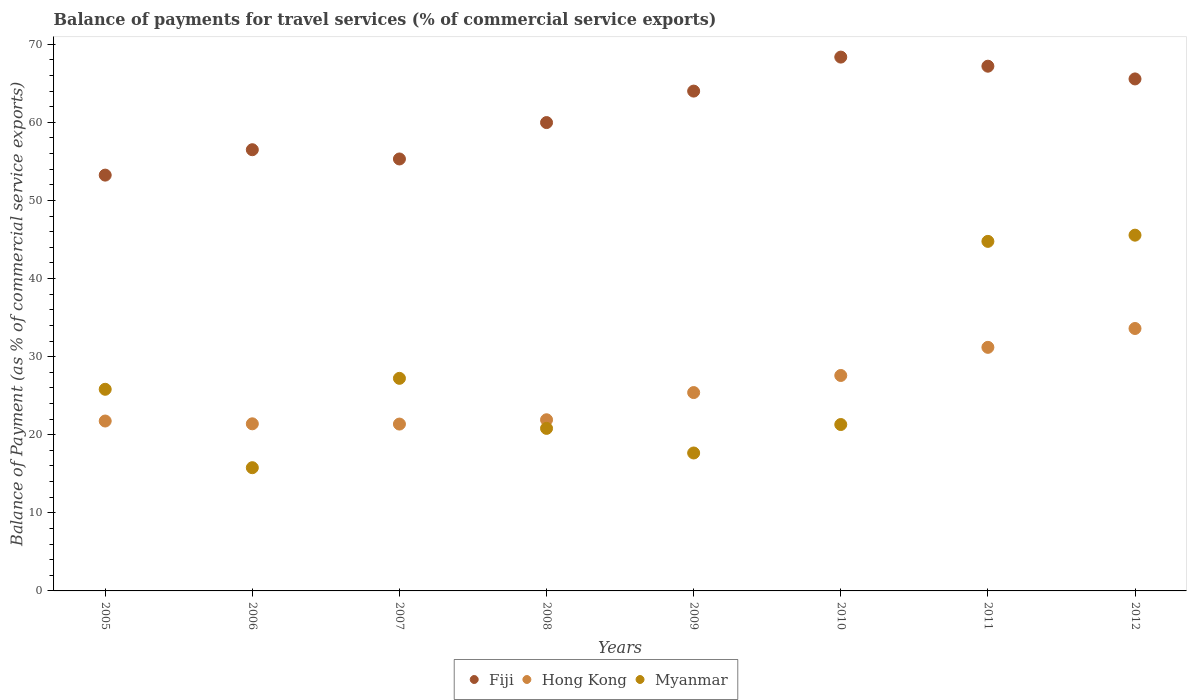Is the number of dotlines equal to the number of legend labels?
Keep it short and to the point. Yes. What is the balance of payments for travel services in Myanmar in 2009?
Your answer should be compact. 17.66. Across all years, what is the maximum balance of payments for travel services in Fiji?
Ensure brevity in your answer.  68.36. Across all years, what is the minimum balance of payments for travel services in Myanmar?
Provide a short and direct response. 15.78. What is the total balance of payments for travel services in Fiji in the graph?
Your answer should be very brief. 490.14. What is the difference between the balance of payments for travel services in Fiji in 2006 and that in 2010?
Give a very brief answer. -11.86. What is the difference between the balance of payments for travel services in Fiji in 2006 and the balance of payments for travel services in Hong Kong in 2009?
Provide a succinct answer. 31.1. What is the average balance of payments for travel services in Myanmar per year?
Ensure brevity in your answer.  27.36. In the year 2009, what is the difference between the balance of payments for travel services in Fiji and balance of payments for travel services in Myanmar?
Your answer should be very brief. 46.34. In how many years, is the balance of payments for travel services in Hong Kong greater than 10 %?
Make the answer very short. 8. What is the ratio of the balance of payments for travel services in Hong Kong in 2006 to that in 2009?
Your response must be concise. 0.84. What is the difference between the highest and the second highest balance of payments for travel services in Fiji?
Your response must be concise. 1.16. What is the difference between the highest and the lowest balance of payments for travel services in Fiji?
Ensure brevity in your answer.  15.11. In how many years, is the balance of payments for travel services in Fiji greater than the average balance of payments for travel services in Fiji taken over all years?
Offer a very short reply. 4. Is the sum of the balance of payments for travel services in Myanmar in 2005 and 2007 greater than the maximum balance of payments for travel services in Fiji across all years?
Give a very brief answer. No. Is the balance of payments for travel services in Myanmar strictly greater than the balance of payments for travel services in Fiji over the years?
Provide a succinct answer. No. How many years are there in the graph?
Offer a terse response. 8. Are the values on the major ticks of Y-axis written in scientific E-notation?
Your answer should be very brief. No. Does the graph contain grids?
Provide a succinct answer. No. How many legend labels are there?
Your answer should be very brief. 3. How are the legend labels stacked?
Your answer should be compact. Horizontal. What is the title of the graph?
Your answer should be very brief. Balance of payments for travel services (% of commercial service exports). What is the label or title of the Y-axis?
Provide a short and direct response. Balance of Payment (as % of commercial service exports). What is the Balance of Payment (as % of commercial service exports) in Fiji in 2005?
Your answer should be compact. 53.24. What is the Balance of Payment (as % of commercial service exports) of Hong Kong in 2005?
Your answer should be compact. 21.76. What is the Balance of Payment (as % of commercial service exports) of Myanmar in 2005?
Give a very brief answer. 25.82. What is the Balance of Payment (as % of commercial service exports) of Fiji in 2006?
Provide a short and direct response. 56.5. What is the Balance of Payment (as % of commercial service exports) in Hong Kong in 2006?
Provide a succinct answer. 21.4. What is the Balance of Payment (as % of commercial service exports) in Myanmar in 2006?
Provide a succinct answer. 15.78. What is the Balance of Payment (as % of commercial service exports) of Fiji in 2007?
Provide a succinct answer. 55.31. What is the Balance of Payment (as % of commercial service exports) of Hong Kong in 2007?
Provide a succinct answer. 21.37. What is the Balance of Payment (as % of commercial service exports) in Myanmar in 2007?
Provide a succinct answer. 27.22. What is the Balance of Payment (as % of commercial service exports) in Fiji in 2008?
Your answer should be compact. 59.97. What is the Balance of Payment (as % of commercial service exports) of Hong Kong in 2008?
Ensure brevity in your answer.  21.92. What is the Balance of Payment (as % of commercial service exports) of Myanmar in 2008?
Provide a succinct answer. 20.81. What is the Balance of Payment (as % of commercial service exports) of Fiji in 2009?
Your answer should be very brief. 64. What is the Balance of Payment (as % of commercial service exports) in Hong Kong in 2009?
Make the answer very short. 25.4. What is the Balance of Payment (as % of commercial service exports) in Myanmar in 2009?
Ensure brevity in your answer.  17.66. What is the Balance of Payment (as % of commercial service exports) of Fiji in 2010?
Provide a succinct answer. 68.36. What is the Balance of Payment (as % of commercial service exports) of Hong Kong in 2010?
Your answer should be very brief. 27.59. What is the Balance of Payment (as % of commercial service exports) in Myanmar in 2010?
Ensure brevity in your answer.  21.31. What is the Balance of Payment (as % of commercial service exports) in Fiji in 2011?
Ensure brevity in your answer.  67.19. What is the Balance of Payment (as % of commercial service exports) in Hong Kong in 2011?
Give a very brief answer. 31.19. What is the Balance of Payment (as % of commercial service exports) of Myanmar in 2011?
Keep it short and to the point. 44.76. What is the Balance of Payment (as % of commercial service exports) in Fiji in 2012?
Offer a terse response. 65.56. What is the Balance of Payment (as % of commercial service exports) of Hong Kong in 2012?
Your response must be concise. 33.6. What is the Balance of Payment (as % of commercial service exports) of Myanmar in 2012?
Provide a succinct answer. 45.56. Across all years, what is the maximum Balance of Payment (as % of commercial service exports) in Fiji?
Offer a terse response. 68.36. Across all years, what is the maximum Balance of Payment (as % of commercial service exports) in Hong Kong?
Your answer should be very brief. 33.6. Across all years, what is the maximum Balance of Payment (as % of commercial service exports) of Myanmar?
Make the answer very short. 45.56. Across all years, what is the minimum Balance of Payment (as % of commercial service exports) of Fiji?
Offer a terse response. 53.24. Across all years, what is the minimum Balance of Payment (as % of commercial service exports) in Hong Kong?
Make the answer very short. 21.37. Across all years, what is the minimum Balance of Payment (as % of commercial service exports) of Myanmar?
Provide a succinct answer. 15.78. What is the total Balance of Payment (as % of commercial service exports) of Fiji in the graph?
Provide a short and direct response. 490.14. What is the total Balance of Payment (as % of commercial service exports) of Hong Kong in the graph?
Keep it short and to the point. 204.22. What is the total Balance of Payment (as % of commercial service exports) in Myanmar in the graph?
Provide a succinct answer. 218.92. What is the difference between the Balance of Payment (as % of commercial service exports) in Fiji in 2005 and that in 2006?
Ensure brevity in your answer.  -3.25. What is the difference between the Balance of Payment (as % of commercial service exports) in Hong Kong in 2005 and that in 2006?
Your response must be concise. 0.36. What is the difference between the Balance of Payment (as % of commercial service exports) of Myanmar in 2005 and that in 2006?
Ensure brevity in your answer.  10.04. What is the difference between the Balance of Payment (as % of commercial service exports) of Fiji in 2005 and that in 2007?
Your answer should be very brief. -2.07. What is the difference between the Balance of Payment (as % of commercial service exports) in Hong Kong in 2005 and that in 2007?
Keep it short and to the point. 0.39. What is the difference between the Balance of Payment (as % of commercial service exports) of Myanmar in 2005 and that in 2007?
Offer a very short reply. -1.4. What is the difference between the Balance of Payment (as % of commercial service exports) of Fiji in 2005 and that in 2008?
Your response must be concise. -6.73. What is the difference between the Balance of Payment (as % of commercial service exports) of Hong Kong in 2005 and that in 2008?
Provide a short and direct response. -0.16. What is the difference between the Balance of Payment (as % of commercial service exports) in Myanmar in 2005 and that in 2008?
Your answer should be compact. 5.01. What is the difference between the Balance of Payment (as % of commercial service exports) in Fiji in 2005 and that in 2009?
Make the answer very short. -10.76. What is the difference between the Balance of Payment (as % of commercial service exports) in Hong Kong in 2005 and that in 2009?
Offer a terse response. -3.64. What is the difference between the Balance of Payment (as % of commercial service exports) of Myanmar in 2005 and that in 2009?
Your response must be concise. 8.16. What is the difference between the Balance of Payment (as % of commercial service exports) in Fiji in 2005 and that in 2010?
Offer a very short reply. -15.11. What is the difference between the Balance of Payment (as % of commercial service exports) of Hong Kong in 2005 and that in 2010?
Make the answer very short. -5.83. What is the difference between the Balance of Payment (as % of commercial service exports) of Myanmar in 2005 and that in 2010?
Your answer should be very brief. 4.51. What is the difference between the Balance of Payment (as % of commercial service exports) in Fiji in 2005 and that in 2011?
Make the answer very short. -13.95. What is the difference between the Balance of Payment (as % of commercial service exports) of Hong Kong in 2005 and that in 2011?
Offer a terse response. -9.43. What is the difference between the Balance of Payment (as % of commercial service exports) in Myanmar in 2005 and that in 2011?
Provide a short and direct response. -18.94. What is the difference between the Balance of Payment (as % of commercial service exports) in Fiji in 2005 and that in 2012?
Give a very brief answer. -12.32. What is the difference between the Balance of Payment (as % of commercial service exports) in Hong Kong in 2005 and that in 2012?
Keep it short and to the point. -11.85. What is the difference between the Balance of Payment (as % of commercial service exports) of Myanmar in 2005 and that in 2012?
Ensure brevity in your answer.  -19.74. What is the difference between the Balance of Payment (as % of commercial service exports) of Fiji in 2006 and that in 2007?
Provide a short and direct response. 1.18. What is the difference between the Balance of Payment (as % of commercial service exports) in Hong Kong in 2006 and that in 2007?
Offer a terse response. 0.03. What is the difference between the Balance of Payment (as % of commercial service exports) in Myanmar in 2006 and that in 2007?
Provide a short and direct response. -11.44. What is the difference between the Balance of Payment (as % of commercial service exports) in Fiji in 2006 and that in 2008?
Offer a terse response. -3.48. What is the difference between the Balance of Payment (as % of commercial service exports) of Hong Kong in 2006 and that in 2008?
Give a very brief answer. -0.52. What is the difference between the Balance of Payment (as % of commercial service exports) in Myanmar in 2006 and that in 2008?
Provide a short and direct response. -5.03. What is the difference between the Balance of Payment (as % of commercial service exports) of Fiji in 2006 and that in 2009?
Offer a terse response. -7.51. What is the difference between the Balance of Payment (as % of commercial service exports) in Hong Kong in 2006 and that in 2009?
Ensure brevity in your answer.  -4. What is the difference between the Balance of Payment (as % of commercial service exports) of Myanmar in 2006 and that in 2009?
Give a very brief answer. -1.88. What is the difference between the Balance of Payment (as % of commercial service exports) of Fiji in 2006 and that in 2010?
Give a very brief answer. -11.86. What is the difference between the Balance of Payment (as % of commercial service exports) in Hong Kong in 2006 and that in 2010?
Keep it short and to the point. -6.19. What is the difference between the Balance of Payment (as % of commercial service exports) of Myanmar in 2006 and that in 2010?
Your answer should be compact. -5.53. What is the difference between the Balance of Payment (as % of commercial service exports) of Fiji in 2006 and that in 2011?
Ensure brevity in your answer.  -10.69. What is the difference between the Balance of Payment (as % of commercial service exports) of Hong Kong in 2006 and that in 2011?
Provide a succinct answer. -9.79. What is the difference between the Balance of Payment (as % of commercial service exports) in Myanmar in 2006 and that in 2011?
Ensure brevity in your answer.  -28.98. What is the difference between the Balance of Payment (as % of commercial service exports) in Fiji in 2006 and that in 2012?
Your answer should be compact. -9.06. What is the difference between the Balance of Payment (as % of commercial service exports) in Hong Kong in 2006 and that in 2012?
Your answer should be very brief. -12.21. What is the difference between the Balance of Payment (as % of commercial service exports) of Myanmar in 2006 and that in 2012?
Provide a short and direct response. -29.78. What is the difference between the Balance of Payment (as % of commercial service exports) of Fiji in 2007 and that in 2008?
Give a very brief answer. -4.66. What is the difference between the Balance of Payment (as % of commercial service exports) in Hong Kong in 2007 and that in 2008?
Offer a very short reply. -0.55. What is the difference between the Balance of Payment (as % of commercial service exports) of Myanmar in 2007 and that in 2008?
Give a very brief answer. 6.41. What is the difference between the Balance of Payment (as % of commercial service exports) of Fiji in 2007 and that in 2009?
Keep it short and to the point. -8.69. What is the difference between the Balance of Payment (as % of commercial service exports) of Hong Kong in 2007 and that in 2009?
Give a very brief answer. -4.03. What is the difference between the Balance of Payment (as % of commercial service exports) of Myanmar in 2007 and that in 2009?
Provide a succinct answer. 9.56. What is the difference between the Balance of Payment (as % of commercial service exports) in Fiji in 2007 and that in 2010?
Make the answer very short. -13.04. What is the difference between the Balance of Payment (as % of commercial service exports) of Hong Kong in 2007 and that in 2010?
Provide a succinct answer. -6.22. What is the difference between the Balance of Payment (as % of commercial service exports) of Myanmar in 2007 and that in 2010?
Your answer should be very brief. 5.91. What is the difference between the Balance of Payment (as % of commercial service exports) in Fiji in 2007 and that in 2011?
Offer a terse response. -11.88. What is the difference between the Balance of Payment (as % of commercial service exports) of Hong Kong in 2007 and that in 2011?
Your answer should be compact. -9.82. What is the difference between the Balance of Payment (as % of commercial service exports) in Myanmar in 2007 and that in 2011?
Your answer should be very brief. -17.54. What is the difference between the Balance of Payment (as % of commercial service exports) in Fiji in 2007 and that in 2012?
Offer a terse response. -10.25. What is the difference between the Balance of Payment (as % of commercial service exports) in Hong Kong in 2007 and that in 2012?
Your response must be concise. -12.24. What is the difference between the Balance of Payment (as % of commercial service exports) in Myanmar in 2007 and that in 2012?
Provide a succinct answer. -18.33. What is the difference between the Balance of Payment (as % of commercial service exports) of Fiji in 2008 and that in 2009?
Your response must be concise. -4.03. What is the difference between the Balance of Payment (as % of commercial service exports) of Hong Kong in 2008 and that in 2009?
Your response must be concise. -3.48. What is the difference between the Balance of Payment (as % of commercial service exports) of Myanmar in 2008 and that in 2009?
Give a very brief answer. 3.15. What is the difference between the Balance of Payment (as % of commercial service exports) of Fiji in 2008 and that in 2010?
Provide a succinct answer. -8.38. What is the difference between the Balance of Payment (as % of commercial service exports) of Hong Kong in 2008 and that in 2010?
Give a very brief answer. -5.67. What is the difference between the Balance of Payment (as % of commercial service exports) in Myanmar in 2008 and that in 2010?
Your answer should be very brief. -0.49. What is the difference between the Balance of Payment (as % of commercial service exports) in Fiji in 2008 and that in 2011?
Your answer should be compact. -7.22. What is the difference between the Balance of Payment (as % of commercial service exports) of Hong Kong in 2008 and that in 2011?
Keep it short and to the point. -9.27. What is the difference between the Balance of Payment (as % of commercial service exports) in Myanmar in 2008 and that in 2011?
Keep it short and to the point. -23.95. What is the difference between the Balance of Payment (as % of commercial service exports) in Fiji in 2008 and that in 2012?
Your response must be concise. -5.59. What is the difference between the Balance of Payment (as % of commercial service exports) in Hong Kong in 2008 and that in 2012?
Give a very brief answer. -11.69. What is the difference between the Balance of Payment (as % of commercial service exports) in Myanmar in 2008 and that in 2012?
Make the answer very short. -24.74. What is the difference between the Balance of Payment (as % of commercial service exports) of Fiji in 2009 and that in 2010?
Your answer should be compact. -4.35. What is the difference between the Balance of Payment (as % of commercial service exports) in Hong Kong in 2009 and that in 2010?
Give a very brief answer. -2.19. What is the difference between the Balance of Payment (as % of commercial service exports) in Myanmar in 2009 and that in 2010?
Provide a succinct answer. -3.64. What is the difference between the Balance of Payment (as % of commercial service exports) of Fiji in 2009 and that in 2011?
Your response must be concise. -3.19. What is the difference between the Balance of Payment (as % of commercial service exports) of Hong Kong in 2009 and that in 2011?
Provide a succinct answer. -5.79. What is the difference between the Balance of Payment (as % of commercial service exports) in Myanmar in 2009 and that in 2011?
Offer a terse response. -27.1. What is the difference between the Balance of Payment (as % of commercial service exports) of Fiji in 2009 and that in 2012?
Offer a terse response. -1.56. What is the difference between the Balance of Payment (as % of commercial service exports) in Hong Kong in 2009 and that in 2012?
Make the answer very short. -8.21. What is the difference between the Balance of Payment (as % of commercial service exports) of Myanmar in 2009 and that in 2012?
Your answer should be very brief. -27.89. What is the difference between the Balance of Payment (as % of commercial service exports) of Fiji in 2010 and that in 2011?
Your answer should be very brief. 1.16. What is the difference between the Balance of Payment (as % of commercial service exports) in Hong Kong in 2010 and that in 2011?
Your response must be concise. -3.6. What is the difference between the Balance of Payment (as % of commercial service exports) of Myanmar in 2010 and that in 2011?
Your response must be concise. -23.45. What is the difference between the Balance of Payment (as % of commercial service exports) of Fiji in 2010 and that in 2012?
Provide a short and direct response. 2.79. What is the difference between the Balance of Payment (as % of commercial service exports) of Hong Kong in 2010 and that in 2012?
Your response must be concise. -6.02. What is the difference between the Balance of Payment (as % of commercial service exports) of Myanmar in 2010 and that in 2012?
Offer a very short reply. -24.25. What is the difference between the Balance of Payment (as % of commercial service exports) in Fiji in 2011 and that in 2012?
Offer a very short reply. 1.63. What is the difference between the Balance of Payment (as % of commercial service exports) of Hong Kong in 2011 and that in 2012?
Your answer should be very brief. -2.41. What is the difference between the Balance of Payment (as % of commercial service exports) in Myanmar in 2011 and that in 2012?
Offer a very short reply. -0.8. What is the difference between the Balance of Payment (as % of commercial service exports) in Fiji in 2005 and the Balance of Payment (as % of commercial service exports) in Hong Kong in 2006?
Keep it short and to the point. 31.85. What is the difference between the Balance of Payment (as % of commercial service exports) of Fiji in 2005 and the Balance of Payment (as % of commercial service exports) of Myanmar in 2006?
Keep it short and to the point. 37.47. What is the difference between the Balance of Payment (as % of commercial service exports) in Hong Kong in 2005 and the Balance of Payment (as % of commercial service exports) in Myanmar in 2006?
Give a very brief answer. 5.98. What is the difference between the Balance of Payment (as % of commercial service exports) of Fiji in 2005 and the Balance of Payment (as % of commercial service exports) of Hong Kong in 2007?
Give a very brief answer. 31.88. What is the difference between the Balance of Payment (as % of commercial service exports) in Fiji in 2005 and the Balance of Payment (as % of commercial service exports) in Myanmar in 2007?
Provide a short and direct response. 26.02. What is the difference between the Balance of Payment (as % of commercial service exports) in Hong Kong in 2005 and the Balance of Payment (as % of commercial service exports) in Myanmar in 2007?
Keep it short and to the point. -5.46. What is the difference between the Balance of Payment (as % of commercial service exports) in Fiji in 2005 and the Balance of Payment (as % of commercial service exports) in Hong Kong in 2008?
Provide a succinct answer. 31.33. What is the difference between the Balance of Payment (as % of commercial service exports) of Fiji in 2005 and the Balance of Payment (as % of commercial service exports) of Myanmar in 2008?
Your answer should be very brief. 32.43. What is the difference between the Balance of Payment (as % of commercial service exports) of Hong Kong in 2005 and the Balance of Payment (as % of commercial service exports) of Myanmar in 2008?
Your response must be concise. 0.94. What is the difference between the Balance of Payment (as % of commercial service exports) of Fiji in 2005 and the Balance of Payment (as % of commercial service exports) of Hong Kong in 2009?
Give a very brief answer. 27.85. What is the difference between the Balance of Payment (as % of commercial service exports) of Fiji in 2005 and the Balance of Payment (as % of commercial service exports) of Myanmar in 2009?
Give a very brief answer. 35.58. What is the difference between the Balance of Payment (as % of commercial service exports) in Hong Kong in 2005 and the Balance of Payment (as % of commercial service exports) in Myanmar in 2009?
Provide a succinct answer. 4.09. What is the difference between the Balance of Payment (as % of commercial service exports) of Fiji in 2005 and the Balance of Payment (as % of commercial service exports) of Hong Kong in 2010?
Your answer should be very brief. 25.66. What is the difference between the Balance of Payment (as % of commercial service exports) of Fiji in 2005 and the Balance of Payment (as % of commercial service exports) of Myanmar in 2010?
Offer a very short reply. 31.94. What is the difference between the Balance of Payment (as % of commercial service exports) in Hong Kong in 2005 and the Balance of Payment (as % of commercial service exports) in Myanmar in 2010?
Provide a short and direct response. 0.45. What is the difference between the Balance of Payment (as % of commercial service exports) in Fiji in 2005 and the Balance of Payment (as % of commercial service exports) in Hong Kong in 2011?
Give a very brief answer. 22.05. What is the difference between the Balance of Payment (as % of commercial service exports) of Fiji in 2005 and the Balance of Payment (as % of commercial service exports) of Myanmar in 2011?
Offer a very short reply. 8.48. What is the difference between the Balance of Payment (as % of commercial service exports) in Hong Kong in 2005 and the Balance of Payment (as % of commercial service exports) in Myanmar in 2011?
Keep it short and to the point. -23. What is the difference between the Balance of Payment (as % of commercial service exports) in Fiji in 2005 and the Balance of Payment (as % of commercial service exports) in Hong Kong in 2012?
Provide a short and direct response. 19.64. What is the difference between the Balance of Payment (as % of commercial service exports) of Fiji in 2005 and the Balance of Payment (as % of commercial service exports) of Myanmar in 2012?
Ensure brevity in your answer.  7.69. What is the difference between the Balance of Payment (as % of commercial service exports) in Hong Kong in 2005 and the Balance of Payment (as % of commercial service exports) in Myanmar in 2012?
Ensure brevity in your answer.  -23.8. What is the difference between the Balance of Payment (as % of commercial service exports) of Fiji in 2006 and the Balance of Payment (as % of commercial service exports) of Hong Kong in 2007?
Make the answer very short. 35.13. What is the difference between the Balance of Payment (as % of commercial service exports) in Fiji in 2006 and the Balance of Payment (as % of commercial service exports) in Myanmar in 2007?
Offer a terse response. 29.28. What is the difference between the Balance of Payment (as % of commercial service exports) in Hong Kong in 2006 and the Balance of Payment (as % of commercial service exports) in Myanmar in 2007?
Provide a short and direct response. -5.82. What is the difference between the Balance of Payment (as % of commercial service exports) in Fiji in 2006 and the Balance of Payment (as % of commercial service exports) in Hong Kong in 2008?
Provide a short and direct response. 34.58. What is the difference between the Balance of Payment (as % of commercial service exports) in Fiji in 2006 and the Balance of Payment (as % of commercial service exports) in Myanmar in 2008?
Give a very brief answer. 35.68. What is the difference between the Balance of Payment (as % of commercial service exports) of Hong Kong in 2006 and the Balance of Payment (as % of commercial service exports) of Myanmar in 2008?
Provide a succinct answer. 0.59. What is the difference between the Balance of Payment (as % of commercial service exports) of Fiji in 2006 and the Balance of Payment (as % of commercial service exports) of Hong Kong in 2009?
Keep it short and to the point. 31.1. What is the difference between the Balance of Payment (as % of commercial service exports) of Fiji in 2006 and the Balance of Payment (as % of commercial service exports) of Myanmar in 2009?
Your answer should be very brief. 38.83. What is the difference between the Balance of Payment (as % of commercial service exports) in Hong Kong in 2006 and the Balance of Payment (as % of commercial service exports) in Myanmar in 2009?
Your answer should be compact. 3.74. What is the difference between the Balance of Payment (as % of commercial service exports) of Fiji in 2006 and the Balance of Payment (as % of commercial service exports) of Hong Kong in 2010?
Make the answer very short. 28.91. What is the difference between the Balance of Payment (as % of commercial service exports) of Fiji in 2006 and the Balance of Payment (as % of commercial service exports) of Myanmar in 2010?
Provide a short and direct response. 35.19. What is the difference between the Balance of Payment (as % of commercial service exports) of Hong Kong in 2006 and the Balance of Payment (as % of commercial service exports) of Myanmar in 2010?
Make the answer very short. 0.09. What is the difference between the Balance of Payment (as % of commercial service exports) of Fiji in 2006 and the Balance of Payment (as % of commercial service exports) of Hong Kong in 2011?
Offer a very short reply. 25.31. What is the difference between the Balance of Payment (as % of commercial service exports) in Fiji in 2006 and the Balance of Payment (as % of commercial service exports) in Myanmar in 2011?
Your answer should be compact. 11.74. What is the difference between the Balance of Payment (as % of commercial service exports) of Hong Kong in 2006 and the Balance of Payment (as % of commercial service exports) of Myanmar in 2011?
Keep it short and to the point. -23.36. What is the difference between the Balance of Payment (as % of commercial service exports) in Fiji in 2006 and the Balance of Payment (as % of commercial service exports) in Hong Kong in 2012?
Provide a succinct answer. 22.89. What is the difference between the Balance of Payment (as % of commercial service exports) of Fiji in 2006 and the Balance of Payment (as % of commercial service exports) of Myanmar in 2012?
Keep it short and to the point. 10.94. What is the difference between the Balance of Payment (as % of commercial service exports) in Hong Kong in 2006 and the Balance of Payment (as % of commercial service exports) in Myanmar in 2012?
Your answer should be compact. -24.16. What is the difference between the Balance of Payment (as % of commercial service exports) of Fiji in 2007 and the Balance of Payment (as % of commercial service exports) of Hong Kong in 2008?
Provide a short and direct response. 33.4. What is the difference between the Balance of Payment (as % of commercial service exports) of Fiji in 2007 and the Balance of Payment (as % of commercial service exports) of Myanmar in 2008?
Your response must be concise. 34.5. What is the difference between the Balance of Payment (as % of commercial service exports) in Hong Kong in 2007 and the Balance of Payment (as % of commercial service exports) in Myanmar in 2008?
Your answer should be very brief. 0.55. What is the difference between the Balance of Payment (as % of commercial service exports) in Fiji in 2007 and the Balance of Payment (as % of commercial service exports) in Hong Kong in 2009?
Offer a very short reply. 29.91. What is the difference between the Balance of Payment (as % of commercial service exports) in Fiji in 2007 and the Balance of Payment (as % of commercial service exports) in Myanmar in 2009?
Your answer should be very brief. 37.65. What is the difference between the Balance of Payment (as % of commercial service exports) in Hong Kong in 2007 and the Balance of Payment (as % of commercial service exports) in Myanmar in 2009?
Your answer should be very brief. 3.7. What is the difference between the Balance of Payment (as % of commercial service exports) of Fiji in 2007 and the Balance of Payment (as % of commercial service exports) of Hong Kong in 2010?
Provide a succinct answer. 27.72. What is the difference between the Balance of Payment (as % of commercial service exports) in Fiji in 2007 and the Balance of Payment (as % of commercial service exports) in Myanmar in 2010?
Your response must be concise. 34. What is the difference between the Balance of Payment (as % of commercial service exports) of Hong Kong in 2007 and the Balance of Payment (as % of commercial service exports) of Myanmar in 2010?
Provide a short and direct response. 0.06. What is the difference between the Balance of Payment (as % of commercial service exports) of Fiji in 2007 and the Balance of Payment (as % of commercial service exports) of Hong Kong in 2011?
Ensure brevity in your answer.  24.12. What is the difference between the Balance of Payment (as % of commercial service exports) in Fiji in 2007 and the Balance of Payment (as % of commercial service exports) in Myanmar in 2011?
Your answer should be very brief. 10.55. What is the difference between the Balance of Payment (as % of commercial service exports) in Hong Kong in 2007 and the Balance of Payment (as % of commercial service exports) in Myanmar in 2011?
Provide a short and direct response. -23.39. What is the difference between the Balance of Payment (as % of commercial service exports) of Fiji in 2007 and the Balance of Payment (as % of commercial service exports) of Hong Kong in 2012?
Ensure brevity in your answer.  21.71. What is the difference between the Balance of Payment (as % of commercial service exports) of Fiji in 2007 and the Balance of Payment (as % of commercial service exports) of Myanmar in 2012?
Provide a short and direct response. 9.76. What is the difference between the Balance of Payment (as % of commercial service exports) in Hong Kong in 2007 and the Balance of Payment (as % of commercial service exports) in Myanmar in 2012?
Provide a succinct answer. -24.19. What is the difference between the Balance of Payment (as % of commercial service exports) of Fiji in 2008 and the Balance of Payment (as % of commercial service exports) of Hong Kong in 2009?
Offer a terse response. 34.57. What is the difference between the Balance of Payment (as % of commercial service exports) of Fiji in 2008 and the Balance of Payment (as % of commercial service exports) of Myanmar in 2009?
Make the answer very short. 42.31. What is the difference between the Balance of Payment (as % of commercial service exports) in Hong Kong in 2008 and the Balance of Payment (as % of commercial service exports) in Myanmar in 2009?
Provide a succinct answer. 4.25. What is the difference between the Balance of Payment (as % of commercial service exports) of Fiji in 2008 and the Balance of Payment (as % of commercial service exports) of Hong Kong in 2010?
Make the answer very short. 32.38. What is the difference between the Balance of Payment (as % of commercial service exports) in Fiji in 2008 and the Balance of Payment (as % of commercial service exports) in Myanmar in 2010?
Your answer should be compact. 38.66. What is the difference between the Balance of Payment (as % of commercial service exports) of Hong Kong in 2008 and the Balance of Payment (as % of commercial service exports) of Myanmar in 2010?
Offer a very short reply. 0.61. What is the difference between the Balance of Payment (as % of commercial service exports) of Fiji in 2008 and the Balance of Payment (as % of commercial service exports) of Hong Kong in 2011?
Keep it short and to the point. 28.78. What is the difference between the Balance of Payment (as % of commercial service exports) of Fiji in 2008 and the Balance of Payment (as % of commercial service exports) of Myanmar in 2011?
Offer a terse response. 15.21. What is the difference between the Balance of Payment (as % of commercial service exports) of Hong Kong in 2008 and the Balance of Payment (as % of commercial service exports) of Myanmar in 2011?
Ensure brevity in your answer.  -22.84. What is the difference between the Balance of Payment (as % of commercial service exports) of Fiji in 2008 and the Balance of Payment (as % of commercial service exports) of Hong Kong in 2012?
Your answer should be compact. 26.37. What is the difference between the Balance of Payment (as % of commercial service exports) of Fiji in 2008 and the Balance of Payment (as % of commercial service exports) of Myanmar in 2012?
Offer a very short reply. 14.42. What is the difference between the Balance of Payment (as % of commercial service exports) of Hong Kong in 2008 and the Balance of Payment (as % of commercial service exports) of Myanmar in 2012?
Your answer should be compact. -23.64. What is the difference between the Balance of Payment (as % of commercial service exports) in Fiji in 2009 and the Balance of Payment (as % of commercial service exports) in Hong Kong in 2010?
Make the answer very short. 36.41. What is the difference between the Balance of Payment (as % of commercial service exports) in Fiji in 2009 and the Balance of Payment (as % of commercial service exports) in Myanmar in 2010?
Your answer should be compact. 42.7. What is the difference between the Balance of Payment (as % of commercial service exports) of Hong Kong in 2009 and the Balance of Payment (as % of commercial service exports) of Myanmar in 2010?
Your answer should be compact. 4.09. What is the difference between the Balance of Payment (as % of commercial service exports) of Fiji in 2009 and the Balance of Payment (as % of commercial service exports) of Hong Kong in 2011?
Offer a very short reply. 32.81. What is the difference between the Balance of Payment (as % of commercial service exports) of Fiji in 2009 and the Balance of Payment (as % of commercial service exports) of Myanmar in 2011?
Ensure brevity in your answer.  19.24. What is the difference between the Balance of Payment (as % of commercial service exports) of Hong Kong in 2009 and the Balance of Payment (as % of commercial service exports) of Myanmar in 2011?
Make the answer very short. -19.36. What is the difference between the Balance of Payment (as % of commercial service exports) of Fiji in 2009 and the Balance of Payment (as % of commercial service exports) of Hong Kong in 2012?
Your answer should be very brief. 30.4. What is the difference between the Balance of Payment (as % of commercial service exports) in Fiji in 2009 and the Balance of Payment (as % of commercial service exports) in Myanmar in 2012?
Make the answer very short. 18.45. What is the difference between the Balance of Payment (as % of commercial service exports) in Hong Kong in 2009 and the Balance of Payment (as % of commercial service exports) in Myanmar in 2012?
Offer a terse response. -20.16. What is the difference between the Balance of Payment (as % of commercial service exports) of Fiji in 2010 and the Balance of Payment (as % of commercial service exports) of Hong Kong in 2011?
Your response must be concise. 37.17. What is the difference between the Balance of Payment (as % of commercial service exports) of Fiji in 2010 and the Balance of Payment (as % of commercial service exports) of Myanmar in 2011?
Give a very brief answer. 23.6. What is the difference between the Balance of Payment (as % of commercial service exports) of Hong Kong in 2010 and the Balance of Payment (as % of commercial service exports) of Myanmar in 2011?
Offer a terse response. -17.17. What is the difference between the Balance of Payment (as % of commercial service exports) of Fiji in 2010 and the Balance of Payment (as % of commercial service exports) of Hong Kong in 2012?
Offer a very short reply. 34.75. What is the difference between the Balance of Payment (as % of commercial service exports) in Fiji in 2010 and the Balance of Payment (as % of commercial service exports) in Myanmar in 2012?
Make the answer very short. 22.8. What is the difference between the Balance of Payment (as % of commercial service exports) in Hong Kong in 2010 and the Balance of Payment (as % of commercial service exports) in Myanmar in 2012?
Offer a terse response. -17.97. What is the difference between the Balance of Payment (as % of commercial service exports) in Fiji in 2011 and the Balance of Payment (as % of commercial service exports) in Hong Kong in 2012?
Offer a very short reply. 33.59. What is the difference between the Balance of Payment (as % of commercial service exports) of Fiji in 2011 and the Balance of Payment (as % of commercial service exports) of Myanmar in 2012?
Give a very brief answer. 21.64. What is the difference between the Balance of Payment (as % of commercial service exports) in Hong Kong in 2011 and the Balance of Payment (as % of commercial service exports) in Myanmar in 2012?
Your answer should be compact. -14.37. What is the average Balance of Payment (as % of commercial service exports) in Fiji per year?
Your answer should be compact. 61.27. What is the average Balance of Payment (as % of commercial service exports) in Hong Kong per year?
Provide a succinct answer. 25.53. What is the average Balance of Payment (as % of commercial service exports) in Myanmar per year?
Offer a very short reply. 27.36. In the year 2005, what is the difference between the Balance of Payment (as % of commercial service exports) of Fiji and Balance of Payment (as % of commercial service exports) of Hong Kong?
Your answer should be compact. 31.49. In the year 2005, what is the difference between the Balance of Payment (as % of commercial service exports) of Fiji and Balance of Payment (as % of commercial service exports) of Myanmar?
Your answer should be very brief. 27.42. In the year 2005, what is the difference between the Balance of Payment (as % of commercial service exports) of Hong Kong and Balance of Payment (as % of commercial service exports) of Myanmar?
Provide a short and direct response. -4.06. In the year 2006, what is the difference between the Balance of Payment (as % of commercial service exports) of Fiji and Balance of Payment (as % of commercial service exports) of Hong Kong?
Make the answer very short. 35.1. In the year 2006, what is the difference between the Balance of Payment (as % of commercial service exports) of Fiji and Balance of Payment (as % of commercial service exports) of Myanmar?
Your answer should be compact. 40.72. In the year 2006, what is the difference between the Balance of Payment (as % of commercial service exports) of Hong Kong and Balance of Payment (as % of commercial service exports) of Myanmar?
Your answer should be very brief. 5.62. In the year 2007, what is the difference between the Balance of Payment (as % of commercial service exports) of Fiji and Balance of Payment (as % of commercial service exports) of Hong Kong?
Make the answer very short. 33.95. In the year 2007, what is the difference between the Balance of Payment (as % of commercial service exports) of Fiji and Balance of Payment (as % of commercial service exports) of Myanmar?
Your answer should be very brief. 28.09. In the year 2007, what is the difference between the Balance of Payment (as % of commercial service exports) of Hong Kong and Balance of Payment (as % of commercial service exports) of Myanmar?
Make the answer very short. -5.86. In the year 2008, what is the difference between the Balance of Payment (as % of commercial service exports) of Fiji and Balance of Payment (as % of commercial service exports) of Hong Kong?
Offer a very short reply. 38.06. In the year 2008, what is the difference between the Balance of Payment (as % of commercial service exports) in Fiji and Balance of Payment (as % of commercial service exports) in Myanmar?
Offer a very short reply. 39.16. In the year 2008, what is the difference between the Balance of Payment (as % of commercial service exports) of Hong Kong and Balance of Payment (as % of commercial service exports) of Myanmar?
Make the answer very short. 1.1. In the year 2009, what is the difference between the Balance of Payment (as % of commercial service exports) in Fiji and Balance of Payment (as % of commercial service exports) in Hong Kong?
Keep it short and to the point. 38.6. In the year 2009, what is the difference between the Balance of Payment (as % of commercial service exports) in Fiji and Balance of Payment (as % of commercial service exports) in Myanmar?
Your response must be concise. 46.34. In the year 2009, what is the difference between the Balance of Payment (as % of commercial service exports) of Hong Kong and Balance of Payment (as % of commercial service exports) of Myanmar?
Provide a short and direct response. 7.74. In the year 2010, what is the difference between the Balance of Payment (as % of commercial service exports) of Fiji and Balance of Payment (as % of commercial service exports) of Hong Kong?
Offer a terse response. 40.77. In the year 2010, what is the difference between the Balance of Payment (as % of commercial service exports) of Fiji and Balance of Payment (as % of commercial service exports) of Myanmar?
Your answer should be compact. 47.05. In the year 2010, what is the difference between the Balance of Payment (as % of commercial service exports) of Hong Kong and Balance of Payment (as % of commercial service exports) of Myanmar?
Offer a very short reply. 6.28. In the year 2011, what is the difference between the Balance of Payment (as % of commercial service exports) in Fiji and Balance of Payment (as % of commercial service exports) in Hong Kong?
Your response must be concise. 36. In the year 2011, what is the difference between the Balance of Payment (as % of commercial service exports) in Fiji and Balance of Payment (as % of commercial service exports) in Myanmar?
Give a very brief answer. 22.43. In the year 2011, what is the difference between the Balance of Payment (as % of commercial service exports) of Hong Kong and Balance of Payment (as % of commercial service exports) of Myanmar?
Make the answer very short. -13.57. In the year 2012, what is the difference between the Balance of Payment (as % of commercial service exports) of Fiji and Balance of Payment (as % of commercial service exports) of Hong Kong?
Give a very brief answer. 31.96. In the year 2012, what is the difference between the Balance of Payment (as % of commercial service exports) in Fiji and Balance of Payment (as % of commercial service exports) in Myanmar?
Your answer should be compact. 20.01. In the year 2012, what is the difference between the Balance of Payment (as % of commercial service exports) in Hong Kong and Balance of Payment (as % of commercial service exports) in Myanmar?
Your response must be concise. -11.95. What is the ratio of the Balance of Payment (as % of commercial service exports) in Fiji in 2005 to that in 2006?
Your answer should be very brief. 0.94. What is the ratio of the Balance of Payment (as % of commercial service exports) of Hong Kong in 2005 to that in 2006?
Offer a very short reply. 1.02. What is the ratio of the Balance of Payment (as % of commercial service exports) in Myanmar in 2005 to that in 2006?
Provide a short and direct response. 1.64. What is the ratio of the Balance of Payment (as % of commercial service exports) in Fiji in 2005 to that in 2007?
Your response must be concise. 0.96. What is the ratio of the Balance of Payment (as % of commercial service exports) in Hong Kong in 2005 to that in 2007?
Your response must be concise. 1.02. What is the ratio of the Balance of Payment (as % of commercial service exports) of Myanmar in 2005 to that in 2007?
Ensure brevity in your answer.  0.95. What is the ratio of the Balance of Payment (as % of commercial service exports) in Fiji in 2005 to that in 2008?
Keep it short and to the point. 0.89. What is the ratio of the Balance of Payment (as % of commercial service exports) in Hong Kong in 2005 to that in 2008?
Make the answer very short. 0.99. What is the ratio of the Balance of Payment (as % of commercial service exports) in Myanmar in 2005 to that in 2008?
Ensure brevity in your answer.  1.24. What is the ratio of the Balance of Payment (as % of commercial service exports) in Fiji in 2005 to that in 2009?
Offer a terse response. 0.83. What is the ratio of the Balance of Payment (as % of commercial service exports) in Hong Kong in 2005 to that in 2009?
Your response must be concise. 0.86. What is the ratio of the Balance of Payment (as % of commercial service exports) of Myanmar in 2005 to that in 2009?
Offer a terse response. 1.46. What is the ratio of the Balance of Payment (as % of commercial service exports) in Fiji in 2005 to that in 2010?
Offer a terse response. 0.78. What is the ratio of the Balance of Payment (as % of commercial service exports) of Hong Kong in 2005 to that in 2010?
Keep it short and to the point. 0.79. What is the ratio of the Balance of Payment (as % of commercial service exports) of Myanmar in 2005 to that in 2010?
Ensure brevity in your answer.  1.21. What is the ratio of the Balance of Payment (as % of commercial service exports) of Fiji in 2005 to that in 2011?
Your answer should be very brief. 0.79. What is the ratio of the Balance of Payment (as % of commercial service exports) of Hong Kong in 2005 to that in 2011?
Your answer should be compact. 0.7. What is the ratio of the Balance of Payment (as % of commercial service exports) of Myanmar in 2005 to that in 2011?
Ensure brevity in your answer.  0.58. What is the ratio of the Balance of Payment (as % of commercial service exports) in Fiji in 2005 to that in 2012?
Provide a succinct answer. 0.81. What is the ratio of the Balance of Payment (as % of commercial service exports) of Hong Kong in 2005 to that in 2012?
Your response must be concise. 0.65. What is the ratio of the Balance of Payment (as % of commercial service exports) of Myanmar in 2005 to that in 2012?
Your answer should be very brief. 0.57. What is the ratio of the Balance of Payment (as % of commercial service exports) in Fiji in 2006 to that in 2007?
Your answer should be very brief. 1.02. What is the ratio of the Balance of Payment (as % of commercial service exports) in Myanmar in 2006 to that in 2007?
Keep it short and to the point. 0.58. What is the ratio of the Balance of Payment (as % of commercial service exports) in Fiji in 2006 to that in 2008?
Make the answer very short. 0.94. What is the ratio of the Balance of Payment (as % of commercial service exports) of Hong Kong in 2006 to that in 2008?
Give a very brief answer. 0.98. What is the ratio of the Balance of Payment (as % of commercial service exports) of Myanmar in 2006 to that in 2008?
Offer a very short reply. 0.76. What is the ratio of the Balance of Payment (as % of commercial service exports) of Fiji in 2006 to that in 2009?
Your answer should be compact. 0.88. What is the ratio of the Balance of Payment (as % of commercial service exports) of Hong Kong in 2006 to that in 2009?
Give a very brief answer. 0.84. What is the ratio of the Balance of Payment (as % of commercial service exports) in Myanmar in 2006 to that in 2009?
Your answer should be very brief. 0.89. What is the ratio of the Balance of Payment (as % of commercial service exports) of Fiji in 2006 to that in 2010?
Your answer should be very brief. 0.83. What is the ratio of the Balance of Payment (as % of commercial service exports) in Hong Kong in 2006 to that in 2010?
Offer a terse response. 0.78. What is the ratio of the Balance of Payment (as % of commercial service exports) in Myanmar in 2006 to that in 2010?
Keep it short and to the point. 0.74. What is the ratio of the Balance of Payment (as % of commercial service exports) of Fiji in 2006 to that in 2011?
Your answer should be very brief. 0.84. What is the ratio of the Balance of Payment (as % of commercial service exports) of Hong Kong in 2006 to that in 2011?
Provide a short and direct response. 0.69. What is the ratio of the Balance of Payment (as % of commercial service exports) in Myanmar in 2006 to that in 2011?
Provide a succinct answer. 0.35. What is the ratio of the Balance of Payment (as % of commercial service exports) in Fiji in 2006 to that in 2012?
Make the answer very short. 0.86. What is the ratio of the Balance of Payment (as % of commercial service exports) in Hong Kong in 2006 to that in 2012?
Provide a short and direct response. 0.64. What is the ratio of the Balance of Payment (as % of commercial service exports) of Myanmar in 2006 to that in 2012?
Provide a short and direct response. 0.35. What is the ratio of the Balance of Payment (as % of commercial service exports) in Fiji in 2007 to that in 2008?
Your answer should be very brief. 0.92. What is the ratio of the Balance of Payment (as % of commercial service exports) of Hong Kong in 2007 to that in 2008?
Your answer should be compact. 0.97. What is the ratio of the Balance of Payment (as % of commercial service exports) of Myanmar in 2007 to that in 2008?
Offer a terse response. 1.31. What is the ratio of the Balance of Payment (as % of commercial service exports) in Fiji in 2007 to that in 2009?
Offer a terse response. 0.86. What is the ratio of the Balance of Payment (as % of commercial service exports) in Hong Kong in 2007 to that in 2009?
Make the answer very short. 0.84. What is the ratio of the Balance of Payment (as % of commercial service exports) in Myanmar in 2007 to that in 2009?
Your answer should be very brief. 1.54. What is the ratio of the Balance of Payment (as % of commercial service exports) in Fiji in 2007 to that in 2010?
Provide a short and direct response. 0.81. What is the ratio of the Balance of Payment (as % of commercial service exports) of Hong Kong in 2007 to that in 2010?
Ensure brevity in your answer.  0.77. What is the ratio of the Balance of Payment (as % of commercial service exports) of Myanmar in 2007 to that in 2010?
Your response must be concise. 1.28. What is the ratio of the Balance of Payment (as % of commercial service exports) in Fiji in 2007 to that in 2011?
Provide a succinct answer. 0.82. What is the ratio of the Balance of Payment (as % of commercial service exports) of Hong Kong in 2007 to that in 2011?
Offer a very short reply. 0.69. What is the ratio of the Balance of Payment (as % of commercial service exports) of Myanmar in 2007 to that in 2011?
Provide a succinct answer. 0.61. What is the ratio of the Balance of Payment (as % of commercial service exports) of Fiji in 2007 to that in 2012?
Make the answer very short. 0.84. What is the ratio of the Balance of Payment (as % of commercial service exports) in Hong Kong in 2007 to that in 2012?
Provide a succinct answer. 0.64. What is the ratio of the Balance of Payment (as % of commercial service exports) of Myanmar in 2007 to that in 2012?
Offer a terse response. 0.6. What is the ratio of the Balance of Payment (as % of commercial service exports) of Fiji in 2008 to that in 2009?
Your answer should be very brief. 0.94. What is the ratio of the Balance of Payment (as % of commercial service exports) in Hong Kong in 2008 to that in 2009?
Your response must be concise. 0.86. What is the ratio of the Balance of Payment (as % of commercial service exports) of Myanmar in 2008 to that in 2009?
Provide a short and direct response. 1.18. What is the ratio of the Balance of Payment (as % of commercial service exports) of Fiji in 2008 to that in 2010?
Provide a short and direct response. 0.88. What is the ratio of the Balance of Payment (as % of commercial service exports) of Hong Kong in 2008 to that in 2010?
Ensure brevity in your answer.  0.79. What is the ratio of the Balance of Payment (as % of commercial service exports) in Myanmar in 2008 to that in 2010?
Ensure brevity in your answer.  0.98. What is the ratio of the Balance of Payment (as % of commercial service exports) of Fiji in 2008 to that in 2011?
Provide a short and direct response. 0.89. What is the ratio of the Balance of Payment (as % of commercial service exports) of Hong Kong in 2008 to that in 2011?
Your answer should be compact. 0.7. What is the ratio of the Balance of Payment (as % of commercial service exports) of Myanmar in 2008 to that in 2011?
Your response must be concise. 0.47. What is the ratio of the Balance of Payment (as % of commercial service exports) of Fiji in 2008 to that in 2012?
Offer a terse response. 0.91. What is the ratio of the Balance of Payment (as % of commercial service exports) in Hong Kong in 2008 to that in 2012?
Provide a succinct answer. 0.65. What is the ratio of the Balance of Payment (as % of commercial service exports) in Myanmar in 2008 to that in 2012?
Your answer should be compact. 0.46. What is the ratio of the Balance of Payment (as % of commercial service exports) of Fiji in 2009 to that in 2010?
Your response must be concise. 0.94. What is the ratio of the Balance of Payment (as % of commercial service exports) in Hong Kong in 2009 to that in 2010?
Your response must be concise. 0.92. What is the ratio of the Balance of Payment (as % of commercial service exports) of Myanmar in 2009 to that in 2010?
Keep it short and to the point. 0.83. What is the ratio of the Balance of Payment (as % of commercial service exports) of Fiji in 2009 to that in 2011?
Your answer should be compact. 0.95. What is the ratio of the Balance of Payment (as % of commercial service exports) of Hong Kong in 2009 to that in 2011?
Give a very brief answer. 0.81. What is the ratio of the Balance of Payment (as % of commercial service exports) of Myanmar in 2009 to that in 2011?
Provide a succinct answer. 0.39. What is the ratio of the Balance of Payment (as % of commercial service exports) in Fiji in 2009 to that in 2012?
Offer a terse response. 0.98. What is the ratio of the Balance of Payment (as % of commercial service exports) in Hong Kong in 2009 to that in 2012?
Provide a succinct answer. 0.76. What is the ratio of the Balance of Payment (as % of commercial service exports) in Myanmar in 2009 to that in 2012?
Make the answer very short. 0.39. What is the ratio of the Balance of Payment (as % of commercial service exports) of Fiji in 2010 to that in 2011?
Your response must be concise. 1.02. What is the ratio of the Balance of Payment (as % of commercial service exports) in Hong Kong in 2010 to that in 2011?
Offer a very short reply. 0.88. What is the ratio of the Balance of Payment (as % of commercial service exports) of Myanmar in 2010 to that in 2011?
Offer a terse response. 0.48. What is the ratio of the Balance of Payment (as % of commercial service exports) in Fiji in 2010 to that in 2012?
Your answer should be compact. 1.04. What is the ratio of the Balance of Payment (as % of commercial service exports) in Hong Kong in 2010 to that in 2012?
Offer a very short reply. 0.82. What is the ratio of the Balance of Payment (as % of commercial service exports) of Myanmar in 2010 to that in 2012?
Keep it short and to the point. 0.47. What is the ratio of the Balance of Payment (as % of commercial service exports) of Fiji in 2011 to that in 2012?
Offer a very short reply. 1.02. What is the ratio of the Balance of Payment (as % of commercial service exports) of Hong Kong in 2011 to that in 2012?
Your response must be concise. 0.93. What is the ratio of the Balance of Payment (as % of commercial service exports) of Myanmar in 2011 to that in 2012?
Your answer should be very brief. 0.98. What is the difference between the highest and the second highest Balance of Payment (as % of commercial service exports) of Fiji?
Provide a short and direct response. 1.16. What is the difference between the highest and the second highest Balance of Payment (as % of commercial service exports) of Hong Kong?
Make the answer very short. 2.41. What is the difference between the highest and the second highest Balance of Payment (as % of commercial service exports) in Myanmar?
Keep it short and to the point. 0.8. What is the difference between the highest and the lowest Balance of Payment (as % of commercial service exports) in Fiji?
Your answer should be compact. 15.11. What is the difference between the highest and the lowest Balance of Payment (as % of commercial service exports) of Hong Kong?
Your answer should be compact. 12.24. What is the difference between the highest and the lowest Balance of Payment (as % of commercial service exports) of Myanmar?
Offer a very short reply. 29.78. 